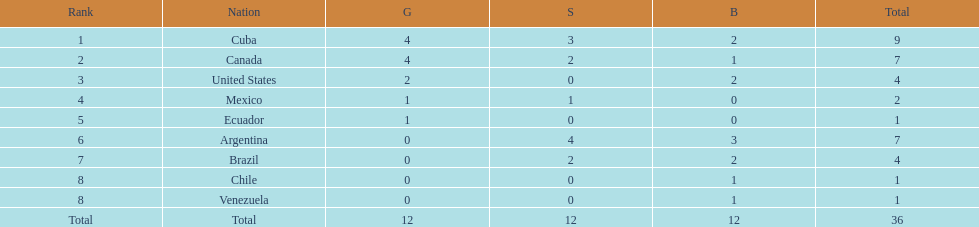Who had more silver medals, cuba or brazil? Cuba. 